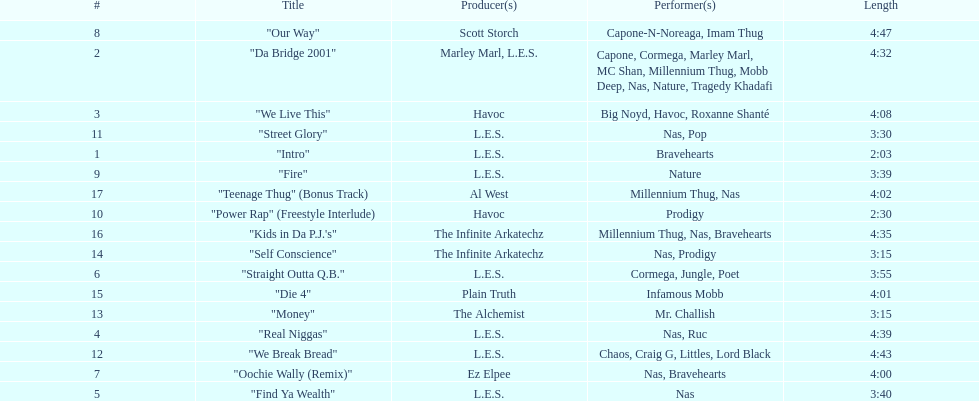What performers were in the last track? Millennium Thug, Nas. 